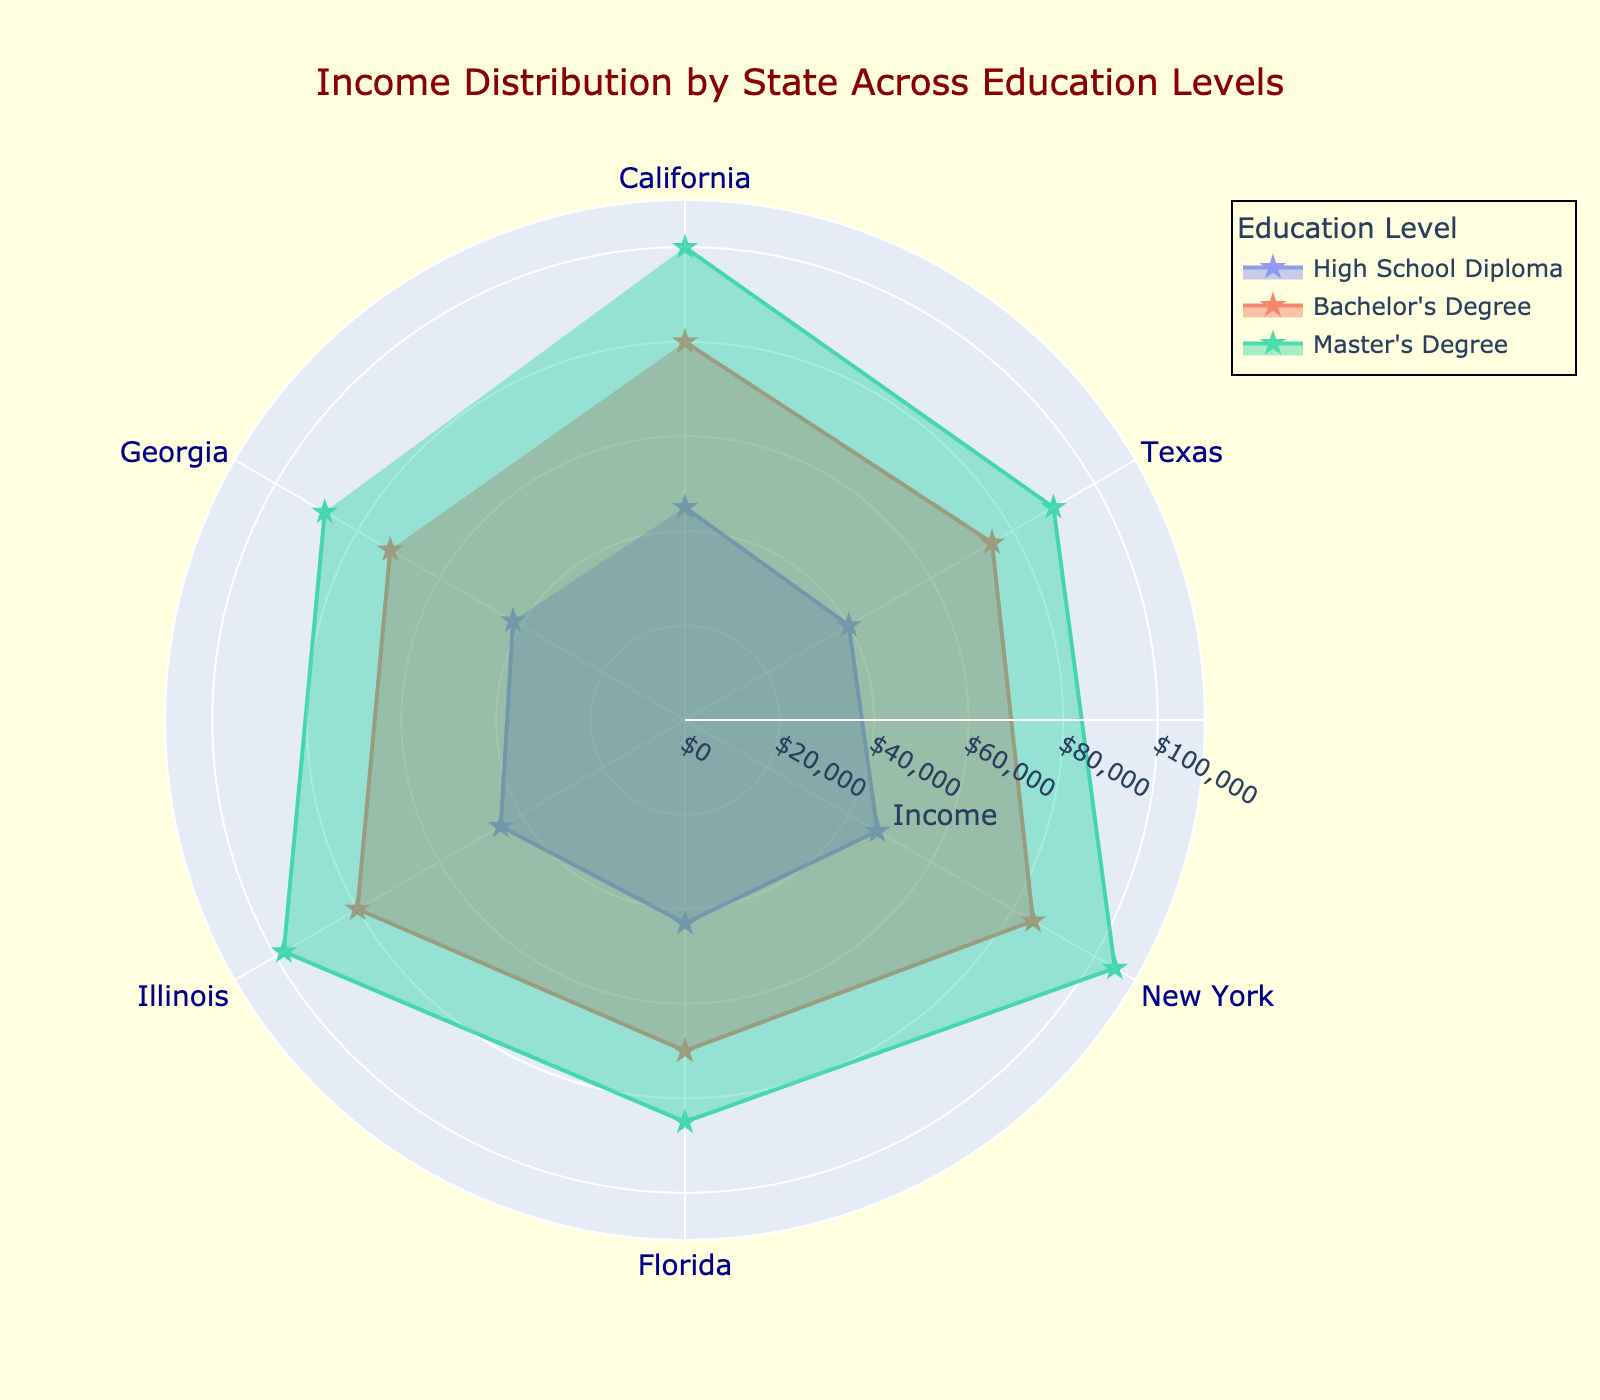What is the highest income for individuals with a Master's degree? Identify the section labeled "Master's Degree" and check the highest data value. New York has the highest income for individuals with a Master's degree at $105,000.
Answer: $105,000 Which state has the lowest income for individuals with a Bachelor's Degree? Look at the section labeled "Bachelor's Degree" and check the values for each state. Florida has the lowest income for individuals with a Bachelor's Degree at $70,000.
Answer: Florida How does the income of a Master's degree holder in Georgia compare to that of a Bachelor's degree holder in New York? Locate Georgia's income data for a Master's degree and New York's income data for a Bachelor's degree. Georgia: $88,000 for Master's, New York: $85,000 for Bachelor's. Georgia's income for a Master's degree is slightly higher by $3,000.
Answer: Georgia's Master's is $3,000 higher Which education level generally shows the highest income across states? Review the general shapes and heights of the polar sections for each education level. The "Master's Degree" section generally has the highest values across states.
Answer: Master's Degree What is the average income difference between a High School Diploma and a Master's Degree across all states? Calculate the difference for each state and then find the average: California ($100,000 - $45,000 = $55,000), Texas ($90,000 - $40,000 = $50,000), New York ($105,000 - $47,000 = $58,000), Florida ($85,000 - $43,000 = $42,000), Illinois ($98,000 - $45,000 = $53,000), Georgia ($88,000 - $42,000 = $46,000). Average: ($55,000 + $50,000 + $58,000 + $42,000 + $53,000 + $46,000) / 6 = $50,666.67
Answer: $50,666.67 Which state is closest to having equal incomes for individuals with a High School Diploma and a Bachelor's Degree? Compare the income differences between High School Diploma and Bachelor's Degree across states. Florida has a difference of $27,000 ($70,000 - $43,000), which is the smallest difference among all states.
Answer: Florida In which state does a Bachelor's Degree yield the most significant income increase over a High School Diploma? Calculate the income increase for each state: California ($80,000 - $45,000 = $35,000), Texas ($75,000 - $40,000 = $35,000), New York ($85,000 - $47,000 = $38,000), Florida ($70,000 - $43,000 = $27,000), Illinois ($80,000 - $45,000 = $35,000), Georgia ($72,000 - $42,000 = $30,000). New York has the highest increase: $38,000.
Answer: New York What is the middle value (median) of incomes for individuals with a High School Diploma across all states? List the incomes for High School Diplomas, then find the median: $40,000 (TX), $42,000 (GA), $43,000 (FL), $45,000 (CA, IL), $47,000 (NY). Arrange them in order: $40,000, $42,000, $43,000, $45,000, $45,000, $47,000. The median is the average of the 3rd and 4th values: ($43,000 + $45,000)/2 = $44,000.
Answer: $44,000 